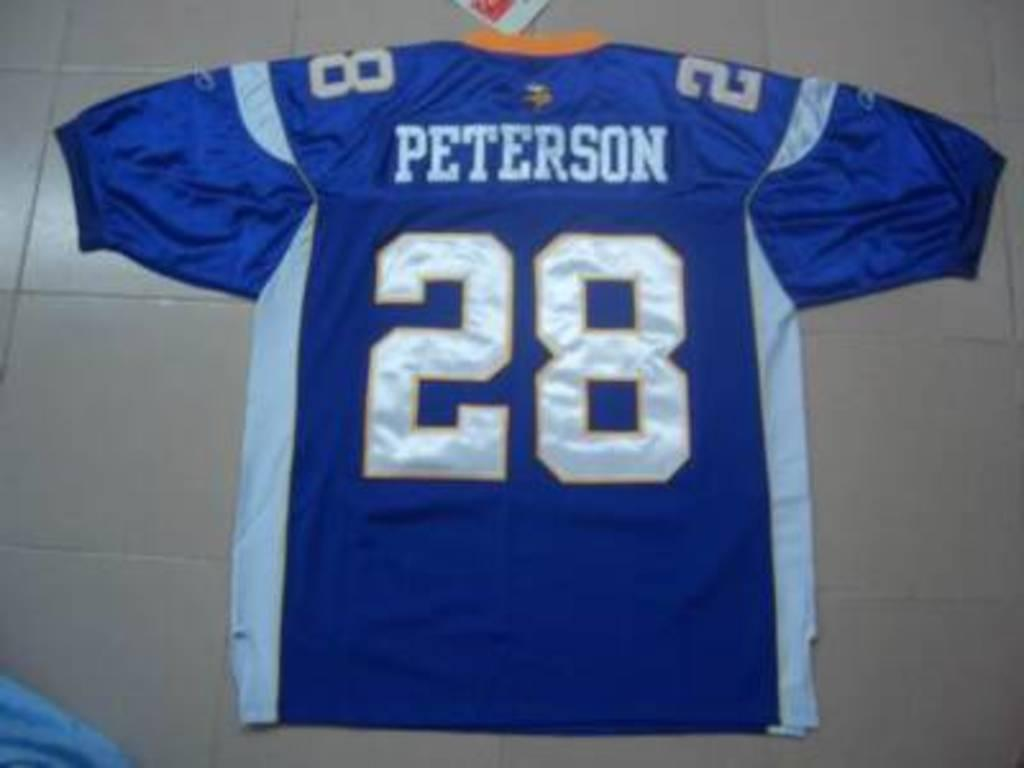<image>
Write a terse but informative summary of the picture. A large blue Peterson, number 28 football jersey. 